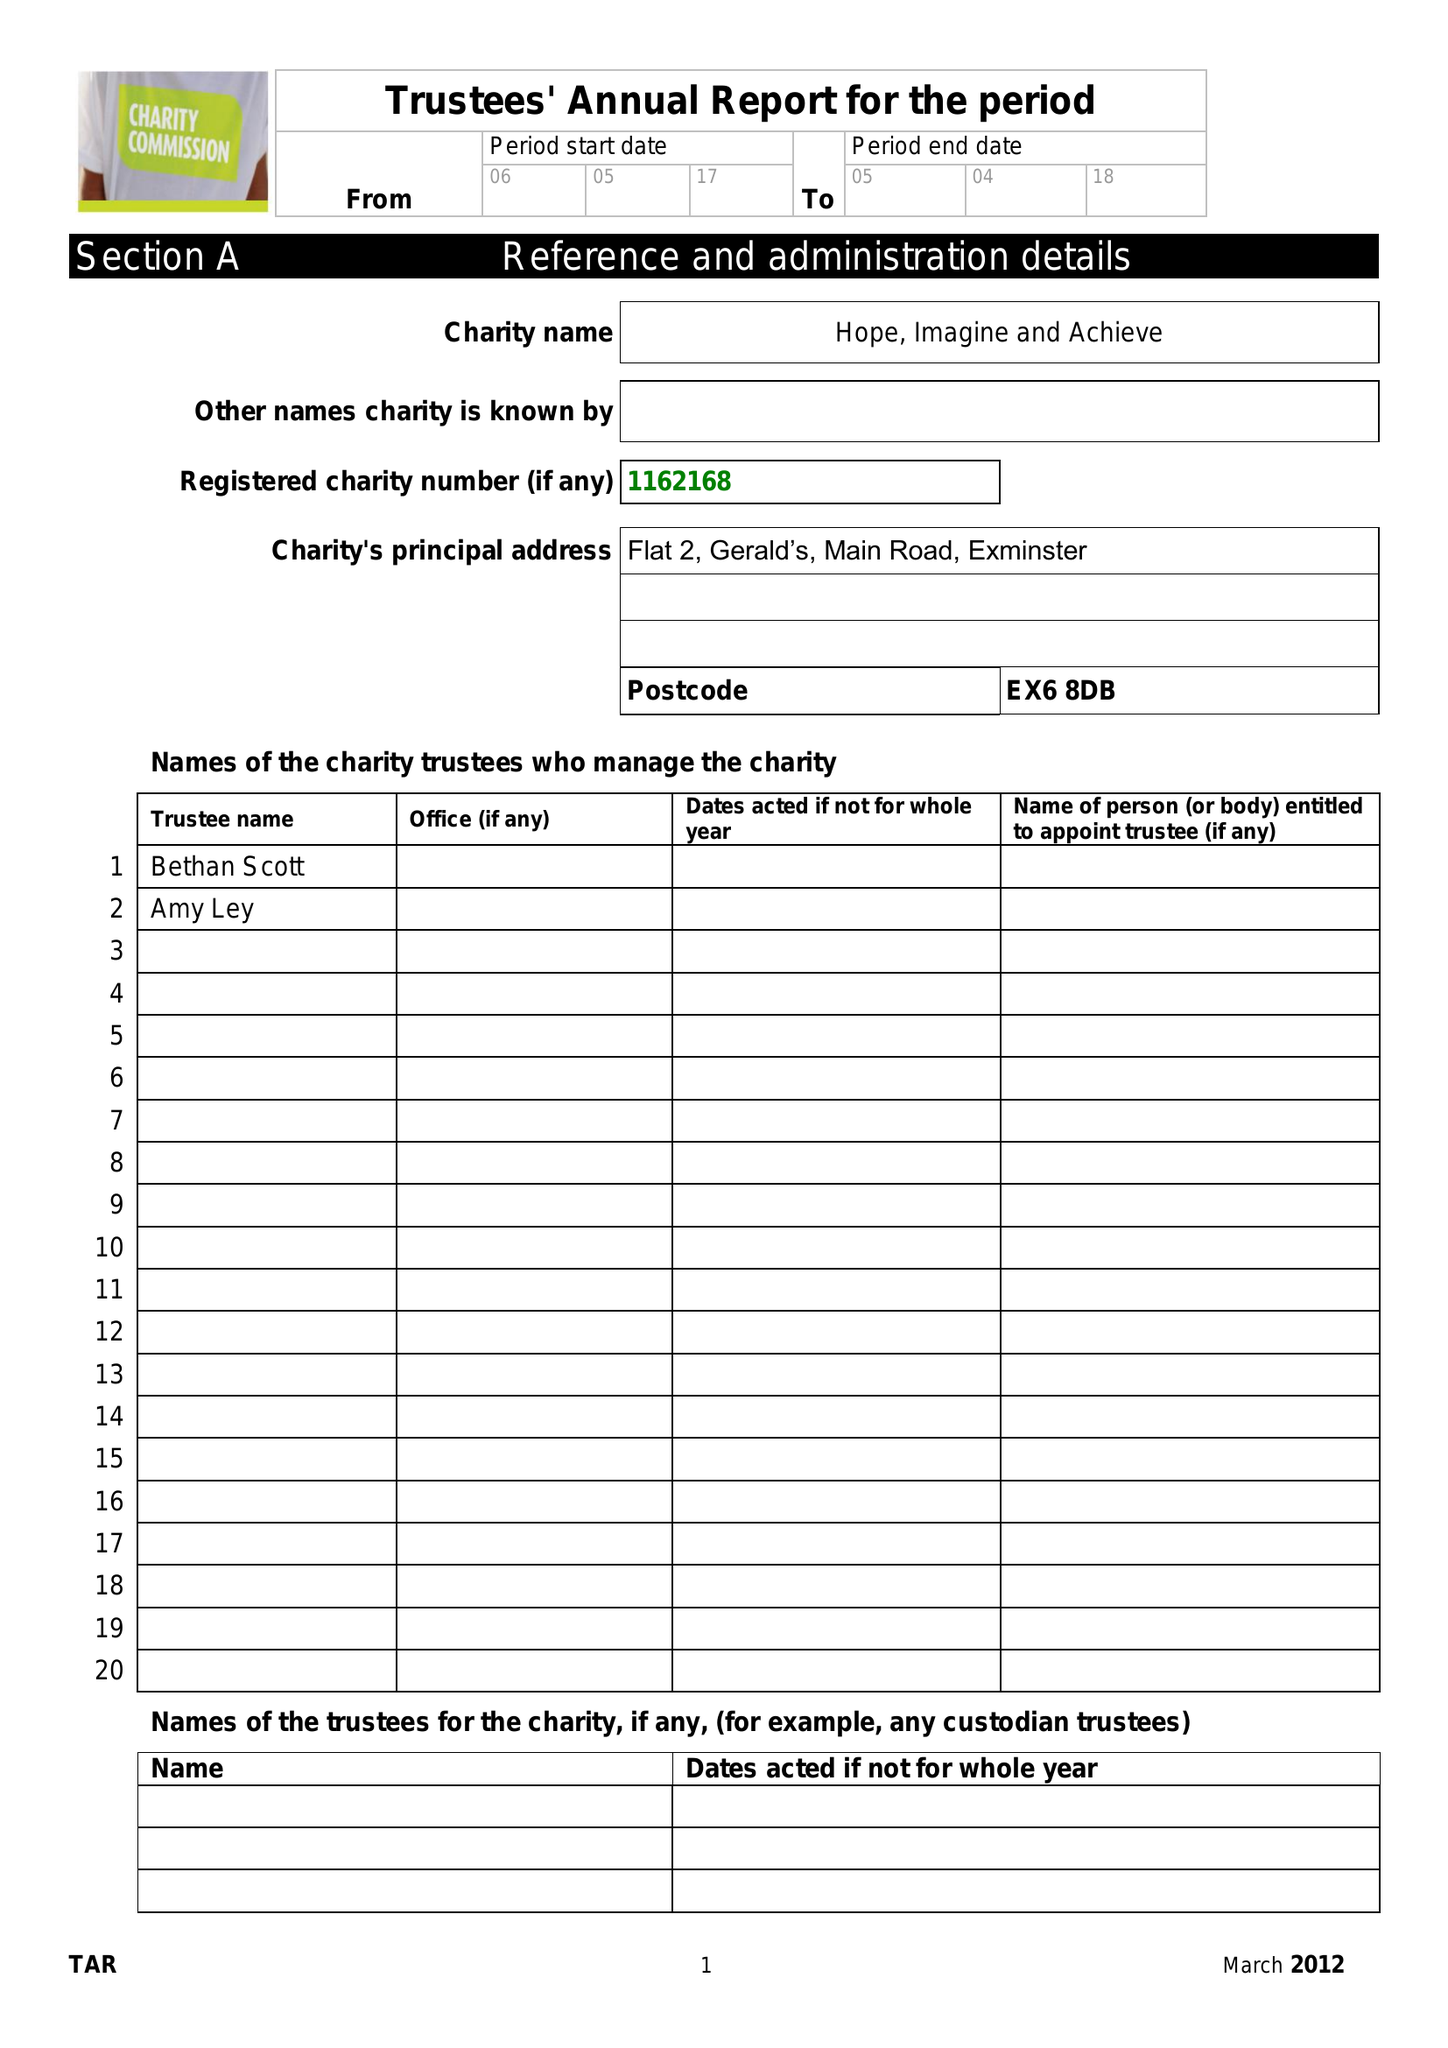What is the value for the address__post_town?
Answer the question using a single word or phrase. EXETER 